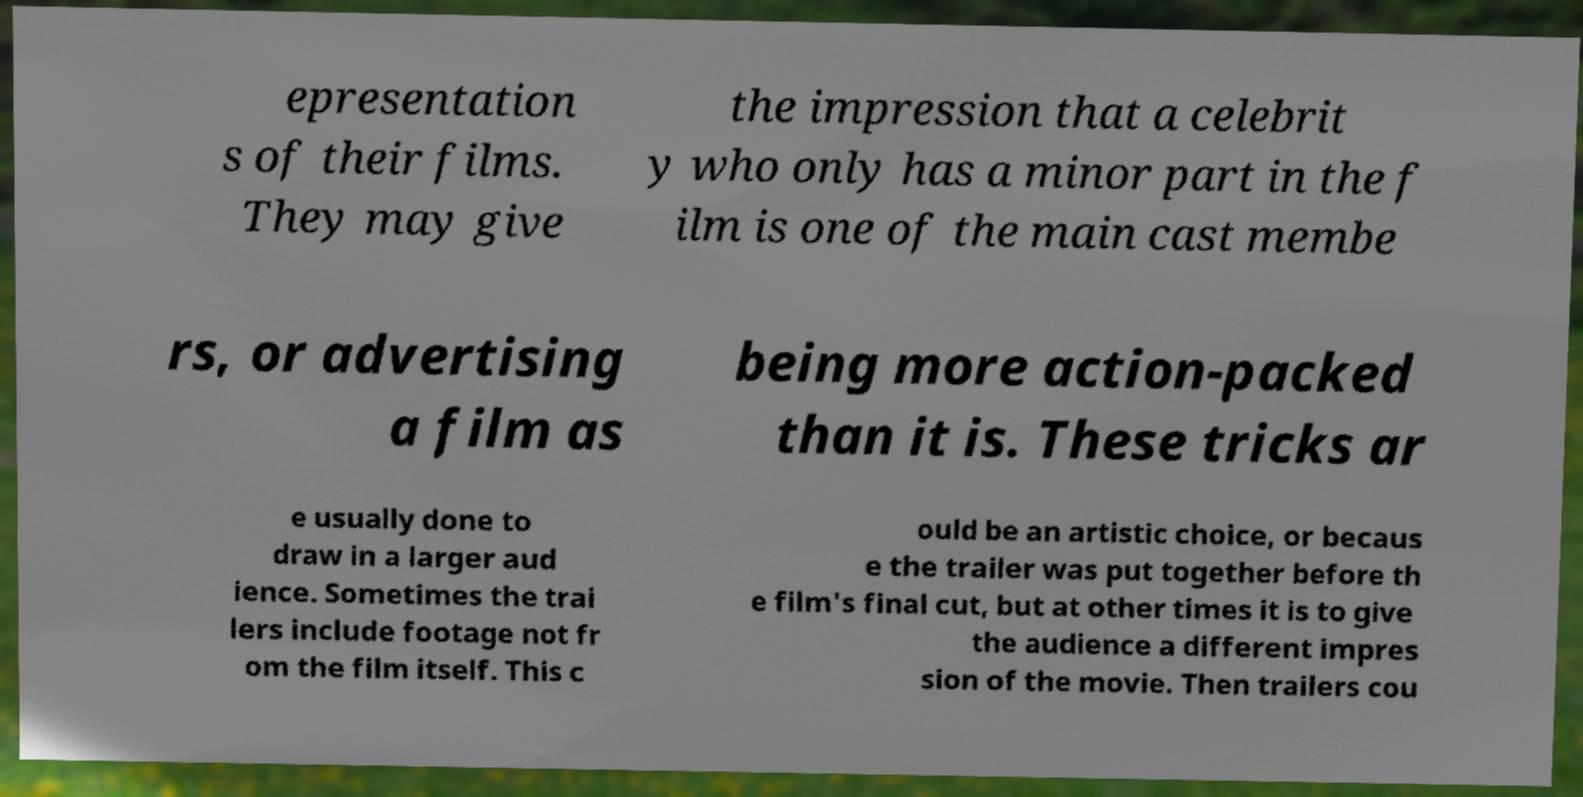Please identify and transcribe the text found in this image. epresentation s of their films. They may give the impression that a celebrit y who only has a minor part in the f ilm is one of the main cast membe rs, or advertising a film as being more action-packed than it is. These tricks ar e usually done to draw in a larger aud ience. Sometimes the trai lers include footage not fr om the film itself. This c ould be an artistic choice, or becaus e the trailer was put together before th e film's final cut, but at other times it is to give the audience a different impres sion of the movie. Then trailers cou 